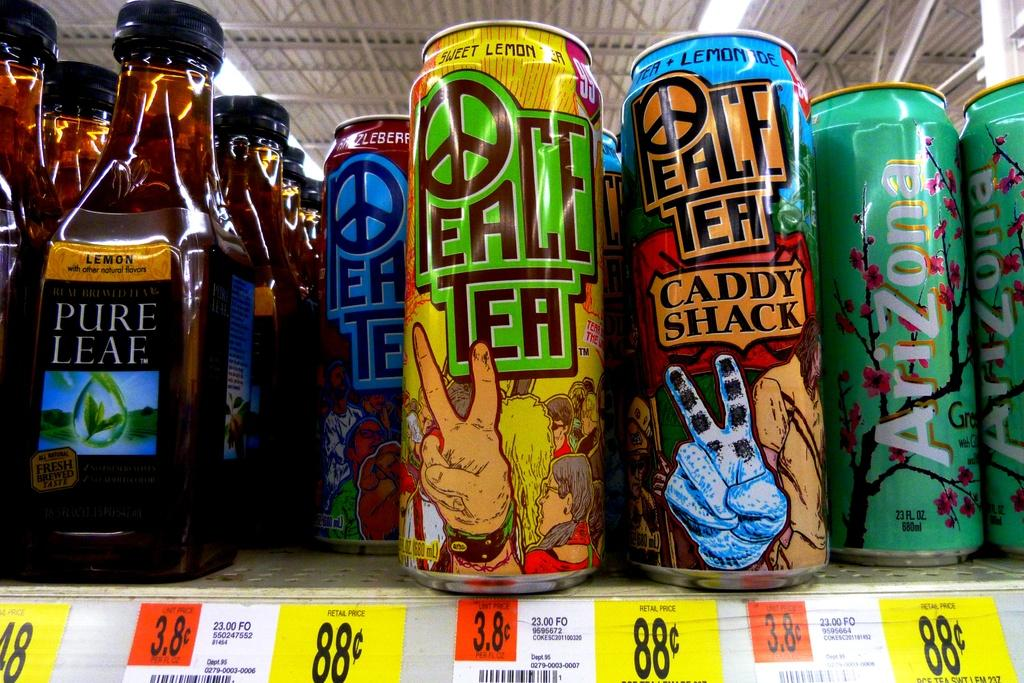What can be seen on the shelf in the image? There are bottles and vans on the shelf in the image. Are there any labels or markings on the vans? Yes, price tags are present on the vans. What is visible in the background of the image? There is a rooftop visible in the image. What type of wire is used to hold the vans on the shelf? There is no wire visible in the image; the vans are resting on the shelf. What is the composition of the iron and copper in the image? There is no iron or copper present in the image. 